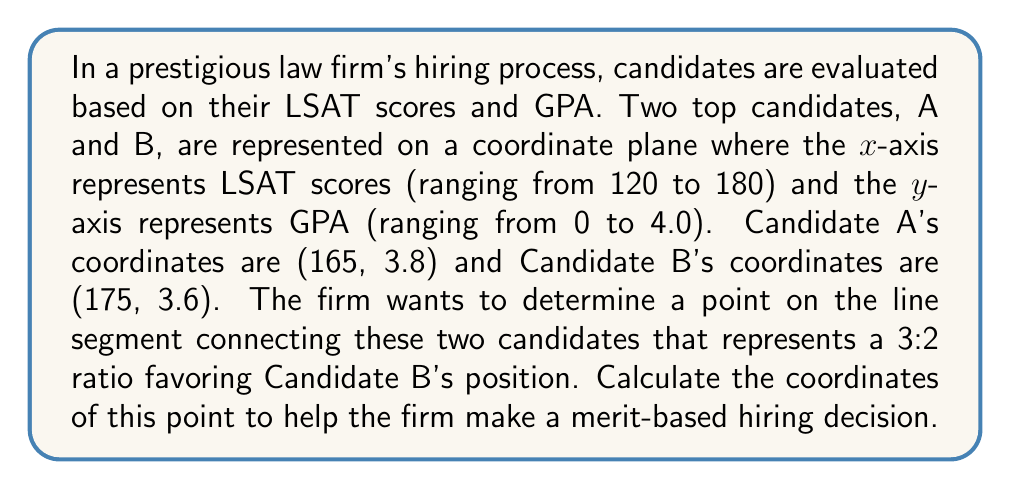Give your solution to this math problem. To solve this problem, we'll use the section formula for dividing a line segment in a given ratio. Let's break it down step-by-step:

1) The general formula for finding the coordinates of a point P(x, y) that divides the line segment AB in the ratio m:n is:

   $$x = \frac{mx_2 + nx_1}{m + n}, \quad y = \frac{my_2 + ny_1}{m + n}$$

   Where (x₁, y₁) are the coordinates of point A and (x₂, y₂) are the coordinates of point B.

2) In our case:
   A(x₁, y₁) = (165, 3.8)
   B(x₂, y₂) = (175, 3.6)
   The ratio is 3:2 favoring B, so m = 3 and n = 2

3) Let's calculate the x-coordinate first:

   $$x = \frac{3(175) + 2(165)}{3 + 2} = \frac{525 + 330}{5} = \frac{855}{5} = 171$$

4) Now let's calculate the y-coordinate:

   $$y = \frac{3(3.6) + 2(3.8)}{3 + 2} = \frac{10.8 + 7.6}{5} = \frac{18.4}{5} = 3.68$$

5) Therefore, the point that divides the line segment AB in a 3:2 ratio favoring B is (171, 3.68).
Answer: The coordinates of the point are (171, 3.68). 